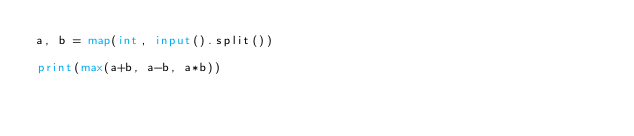Convert code to text. <code><loc_0><loc_0><loc_500><loc_500><_Python_>a, b = map(int, input().split())

print(max(a+b, a-b, a*b))</code> 